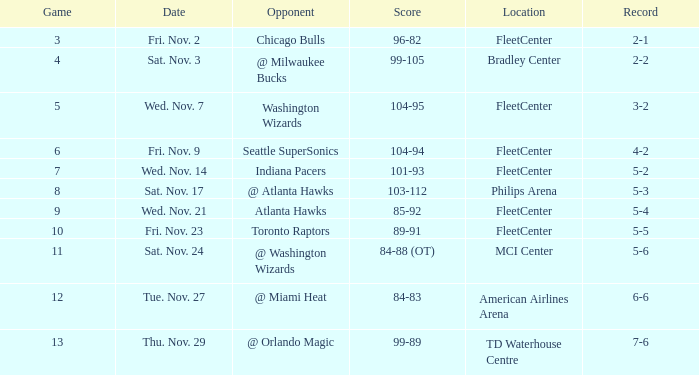What game has a score of 89-91? 10.0. 